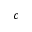Convert formula to latex. <formula><loc_0><loc_0><loc_500><loc_500>c</formula> 